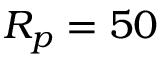Convert formula to latex. <formula><loc_0><loc_0><loc_500><loc_500>R _ { p } = 5 0</formula> 